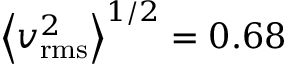Convert formula to latex. <formula><loc_0><loc_0><loc_500><loc_500>\left \langle v _ { r m s } ^ { 2 } \right \rangle ^ { 1 / 2 } = 0 . 6 8</formula> 